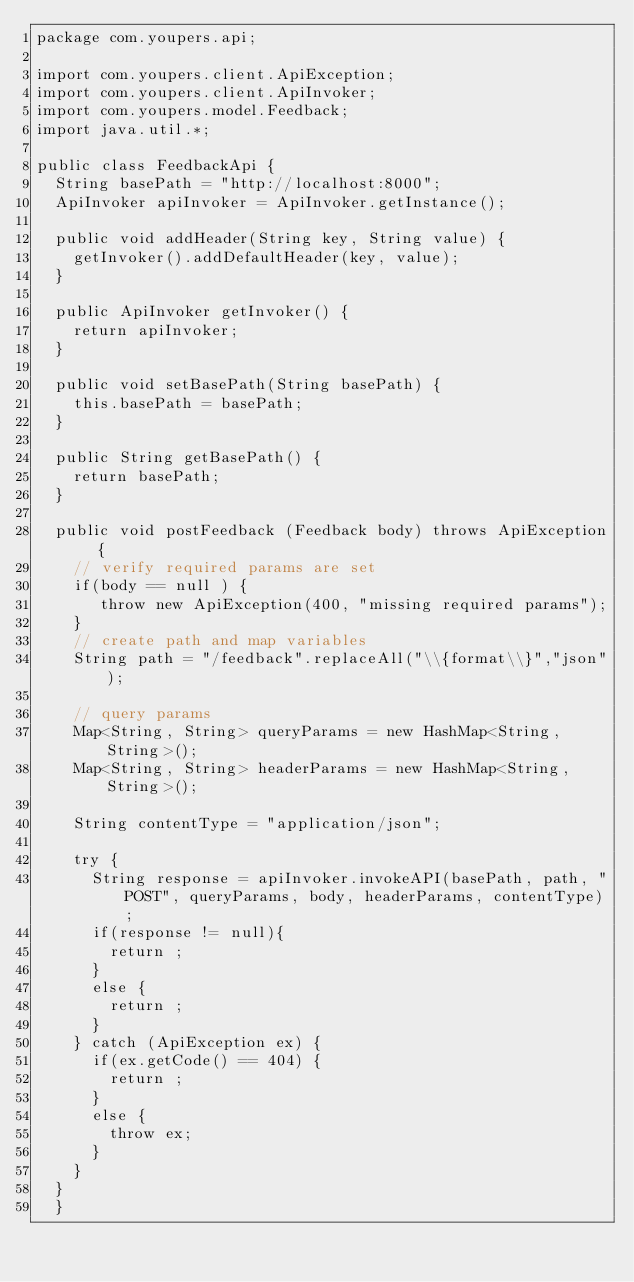Convert code to text. <code><loc_0><loc_0><loc_500><loc_500><_Java_>package com.youpers.api;

import com.youpers.client.ApiException;
import com.youpers.client.ApiInvoker;
import com.youpers.model.Feedback;
import java.util.*;

public class FeedbackApi {
  String basePath = "http://localhost:8000";
  ApiInvoker apiInvoker = ApiInvoker.getInstance();

  public void addHeader(String key, String value) {
    getInvoker().addDefaultHeader(key, value);
  }

  public ApiInvoker getInvoker() {
    return apiInvoker;
  }

  public void setBasePath(String basePath) {
    this.basePath = basePath;
  }

  public String getBasePath() {
    return basePath;
  }

  public void postFeedback (Feedback body) throws ApiException {
    // verify required params are set
    if(body == null ) {
       throw new ApiException(400, "missing required params");
    }
    // create path and map variables
    String path = "/feedback".replaceAll("\\{format\\}","json");

    // query params
    Map<String, String> queryParams = new HashMap<String, String>();
    Map<String, String> headerParams = new HashMap<String, String>();

    String contentType = "application/json";

    try {
      String response = apiInvoker.invokeAPI(basePath, path, "POST", queryParams, body, headerParams, contentType);
      if(response != null){
        return ;
      }
      else {
        return ;
      }
    } catch (ApiException ex) {
      if(ex.getCode() == 404) {
        return ;
      }
      else {
        throw ex;
      }
    }
  }
  }

</code> 